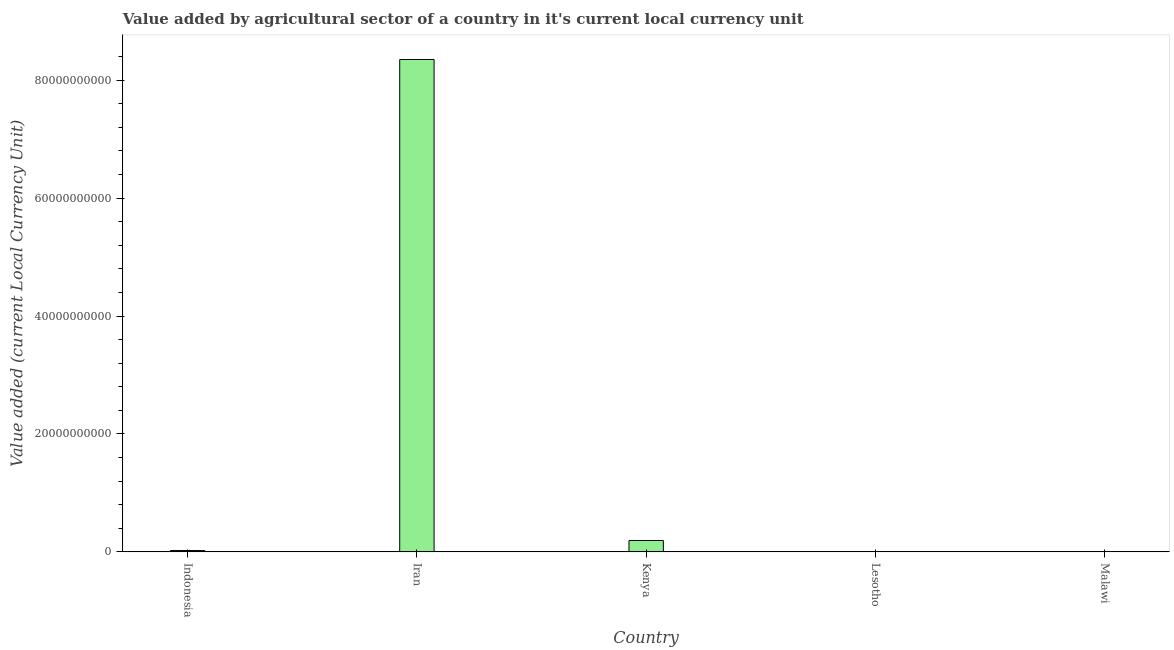Does the graph contain grids?
Your response must be concise. No. What is the title of the graph?
Your answer should be very brief. Value added by agricultural sector of a country in it's current local currency unit. What is the label or title of the Y-axis?
Provide a succinct answer. Value added (current Local Currency Unit). What is the value added by agriculture sector in Indonesia?
Give a very brief answer. 2.27e+08. Across all countries, what is the maximum value added by agriculture sector?
Make the answer very short. 8.35e+1. Across all countries, what is the minimum value added by agriculture sector?
Provide a short and direct response. 2.28e+07. In which country was the value added by agriculture sector maximum?
Keep it short and to the point. Iran. In which country was the value added by agriculture sector minimum?
Make the answer very short. Lesotho. What is the sum of the value added by agriculture sector?
Provide a succinct answer. 8.57e+1. What is the difference between the value added by agriculture sector in Indonesia and Lesotho?
Provide a short and direct response. 2.04e+08. What is the average value added by agriculture sector per country?
Ensure brevity in your answer.  1.71e+1. What is the median value added by agriculture sector?
Your response must be concise. 2.27e+08. What is the ratio of the value added by agriculture sector in Iran to that in Kenya?
Give a very brief answer. 43.27. Is the difference between the value added by agriculture sector in Indonesia and Malawi greater than the difference between any two countries?
Offer a terse response. No. What is the difference between the highest and the second highest value added by agriculture sector?
Provide a short and direct response. 8.16e+1. What is the difference between the highest and the lowest value added by agriculture sector?
Keep it short and to the point. 8.35e+1. How many countries are there in the graph?
Your answer should be very brief. 5. Are the values on the major ticks of Y-axis written in scientific E-notation?
Your answer should be compact. No. What is the Value added (current Local Currency Unit) in Indonesia?
Provide a short and direct response. 2.27e+08. What is the Value added (current Local Currency Unit) in Iran?
Keep it short and to the point. 8.35e+1. What is the Value added (current Local Currency Unit) of Kenya?
Offer a terse response. 1.93e+09. What is the Value added (current Local Currency Unit) of Lesotho?
Your answer should be compact. 2.28e+07. What is the Value added (current Local Currency Unit) in Malawi?
Offer a very short reply. 6.06e+07. What is the difference between the Value added (current Local Currency Unit) in Indonesia and Iran?
Give a very brief answer. -8.33e+1. What is the difference between the Value added (current Local Currency Unit) in Indonesia and Kenya?
Your answer should be very brief. -1.70e+09. What is the difference between the Value added (current Local Currency Unit) in Indonesia and Lesotho?
Provide a short and direct response. 2.04e+08. What is the difference between the Value added (current Local Currency Unit) in Indonesia and Malawi?
Offer a very short reply. 1.66e+08. What is the difference between the Value added (current Local Currency Unit) in Iran and Kenya?
Your answer should be very brief. 8.16e+1. What is the difference between the Value added (current Local Currency Unit) in Iran and Lesotho?
Offer a very short reply. 8.35e+1. What is the difference between the Value added (current Local Currency Unit) in Iran and Malawi?
Make the answer very short. 8.34e+1. What is the difference between the Value added (current Local Currency Unit) in Kenya and Lesotho?
Keep it short and to the point. 1.91e+09. What is the difference between the Value added (current Local Currency Unit) in Kenya and Malawi?
Offer a very short reply. 1.87e+09. What is the difference between the Value added (current Local Currency Unit) in Lesotho and Malawi?
Offer a very short reply. -3.78e+07. What is the ratio of the Value added (current Local Currency Unit) in Indonesia to that in Iran?
Keep it short and to the point. 0. What is the ratio of the Value added (current Local Currency Unit) in Indonesia to that in Kenya?
Your answer should be compact. 0.12. What is the ratio of the Value added (current Local Currency Unit) in Indonesia to that in Lesotho?
Provide a succinct answer. 9.96. What is the ratio of the Value added (current Local Currency Unit) in Indonesia to that in Malawi?
Ensure brevity in your answer.  3.75. What is the ratio of the Value added (current Local Currency Unit) in Iran to that in Kenya?
Your response must be concise. 43.27. What is the ratio of the Value added (current Local Currency Unit) in Iran to that in Lesotho?
Make the answer very short. 3662.55. What is the ratio of the Value added (current Local Currency Unit) in Iran to that in Malawi?
Keep it short and to the point. 1378.03. What is the ratio of the Value added (current Local Currency Unit) in Kenya to that in Lesotho?
Make the answer very short. 84.64. What is the ratio of the Value added (current Local Currency Unit) in Kenya to that in Malawi?
Provide a short and direct response. 31.85. What is the ratio of the Value added (current Local Currency Unit) in Lesotho to that in Malawi?
Your answer should be compact. 0.38. 